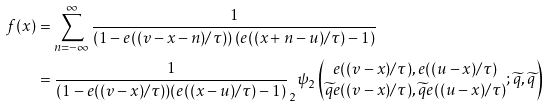<formula> <loc_0><loc_0><loc_500><loc_500>f ( x ) & = \sum _ { n = - \infty } ^ { \infty } \frac { 1 } { \left ( 1 - e ( ( v - x - n ) / \tau ) \right ) \left ( e ( ( x + n - u ) / \tau ) - 1 \right ) } \\ & = \frac { 1 } { ( 1 - e ( ( v - x ) / \tau ) ) ( e ( ( x - u ) / \tau ) - 1 ) } _ { 2 } \psi _ { 2 } \left ( \begin{matrix} e ( ( v - x ) / \tau ) , e ( ( u - x ) / \tau ) \\ \widetilde { q } e ( ( v - x ) / \tau ) , \widetilde { q } e ( ( u - x ) / \tau ) \end{matrix} ; \widetilde { q } , \widetilde { q } \right )</formula> 